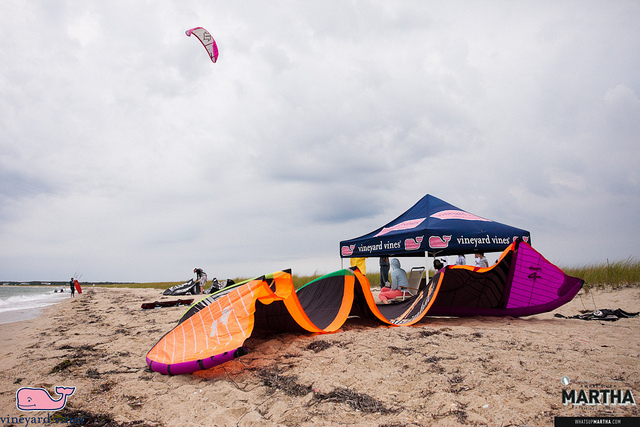Read all the text in this image. vineyard vines vineyard vines MARTHA vineyard vines 